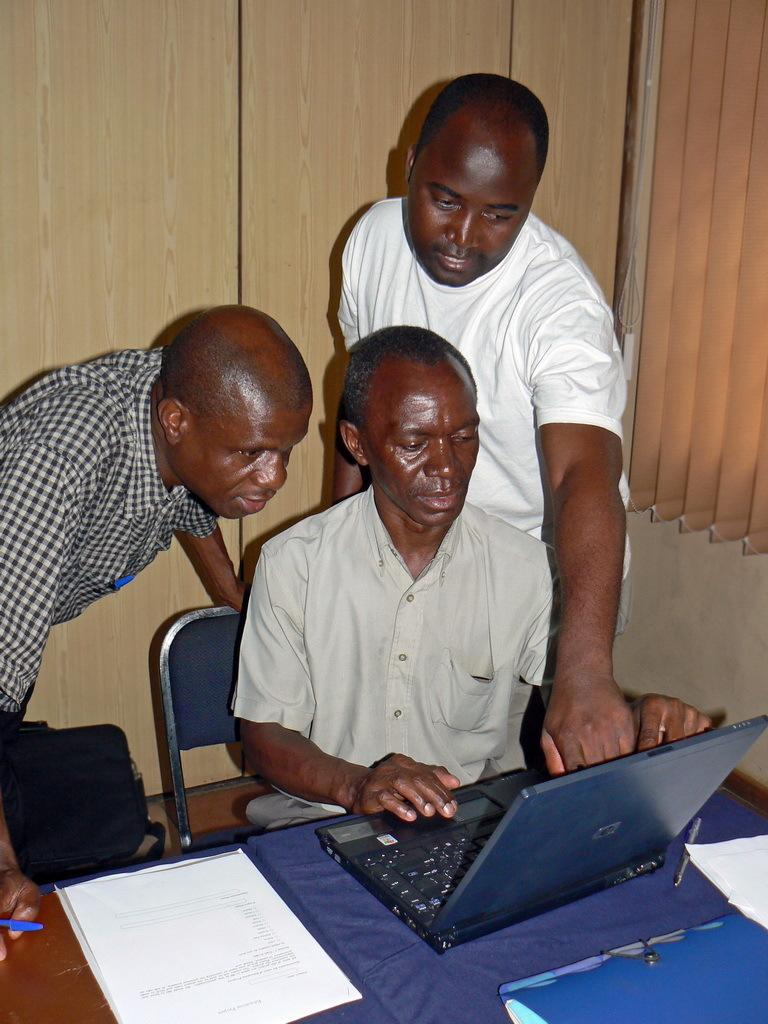How many people are present in the image? There are three people in the image. What is the man on the chair doing? The man is sitting on a chair and using a laptop. What are the other two people doing? The other two people are standing and watching the laptop. What type of dolls can be seen playing with the toys in the image? There are no dolls or toys present in the image. What books are the people reading in the image? There are no books visible in the image. 